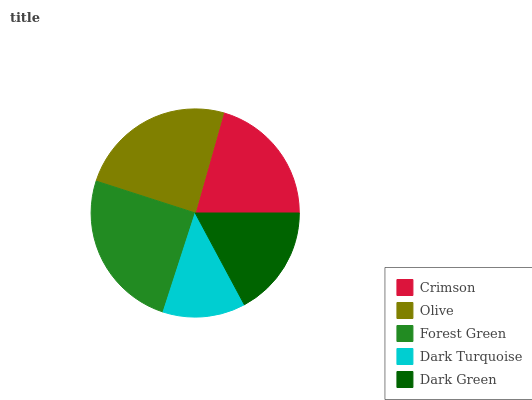Is Dark Turquoise the minimum?
Answer yes or no. Yes. Is Forest Green the maximum?
Answer yes or no. Yes. Is Olive the minimum?
Answer yes or no. No. Is Olive the maximum?
Answer yes or no. No. Is Olive greater than Crimson?
Answer yes or no. Yes. Is Crimson less than Olive?
Answer yes or no. Yes. Is Crimson greater than Olive?
Answer yes or no. No. Is Olive less than Crimson?
Answer yes or no. No. Is Crimson the high median?
Answer yes or no. Yes. Is Crimson the low median?
Answer yes or no. Yes. Is Olive the high median?
Answer yes or no. No. Is Olive the low median?
Answer yes or no. No. 